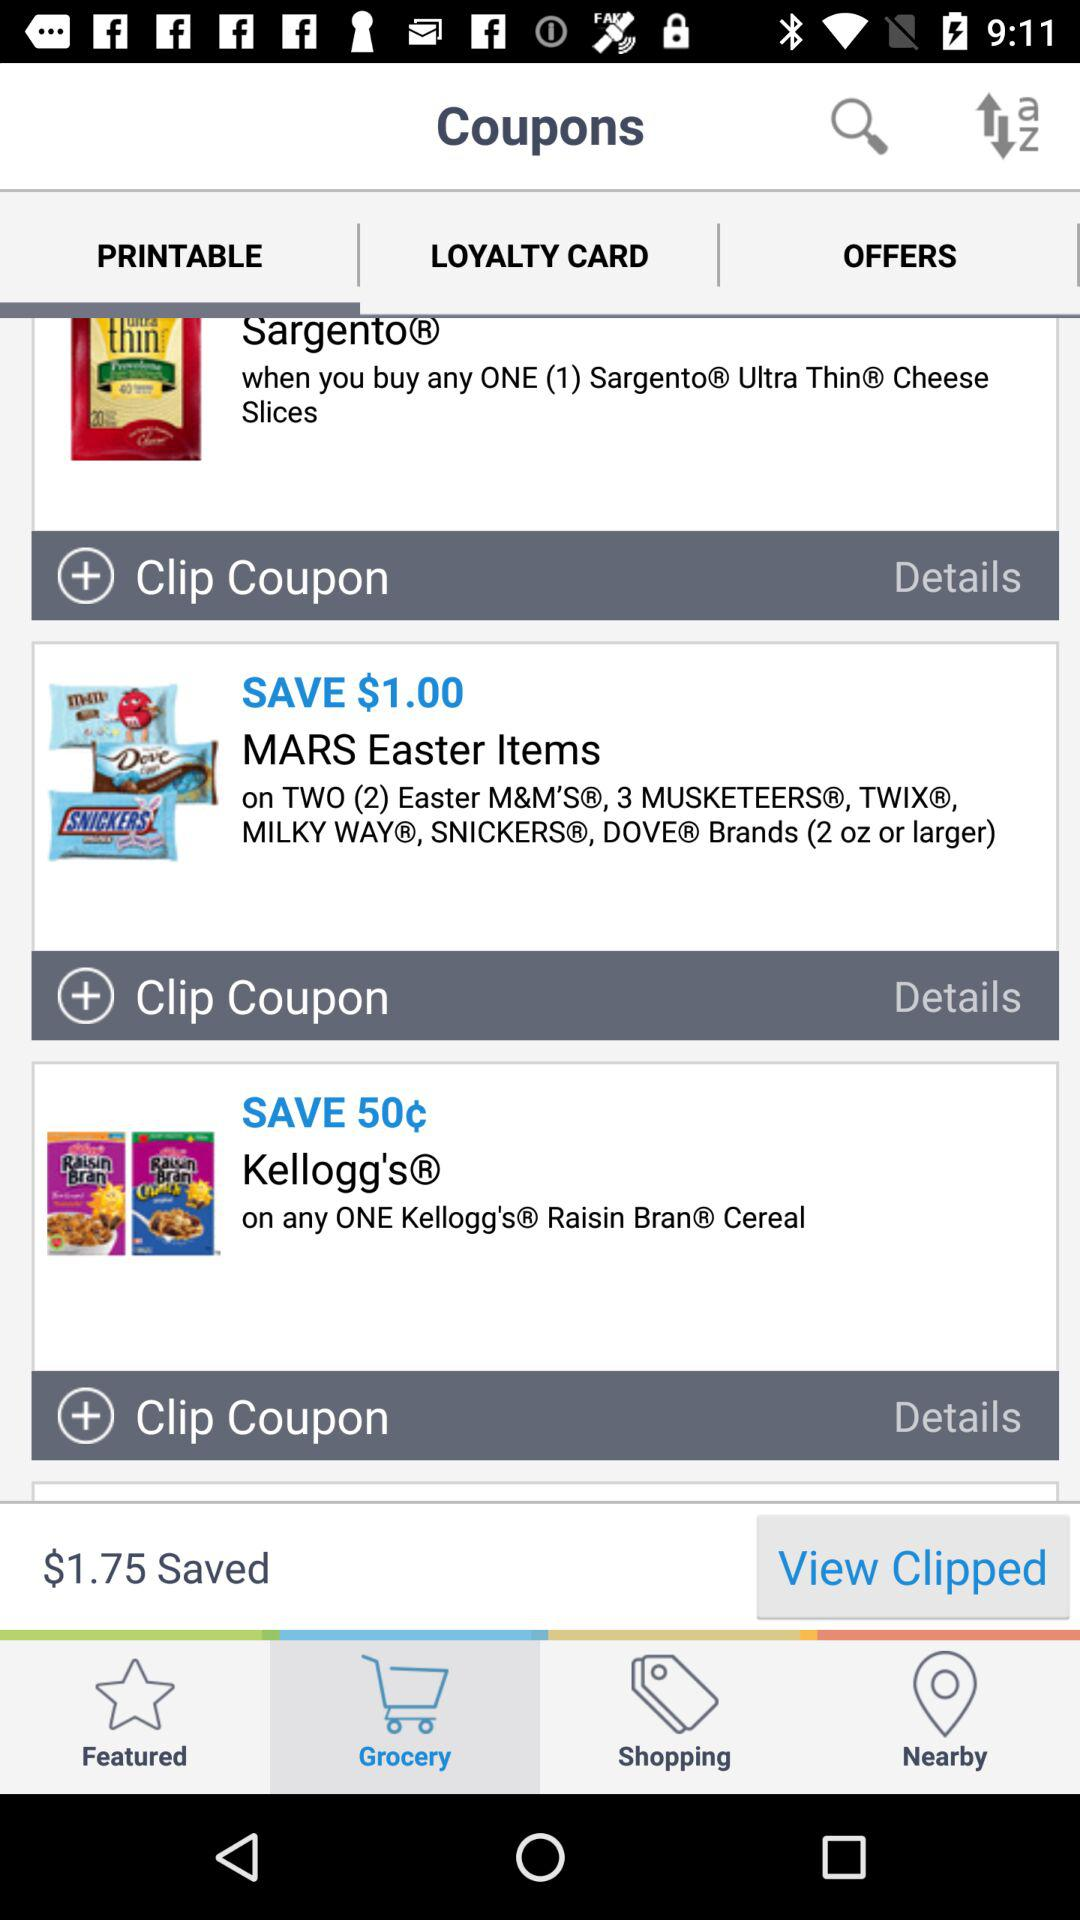How much money is saved? The money saved is $1.75. 